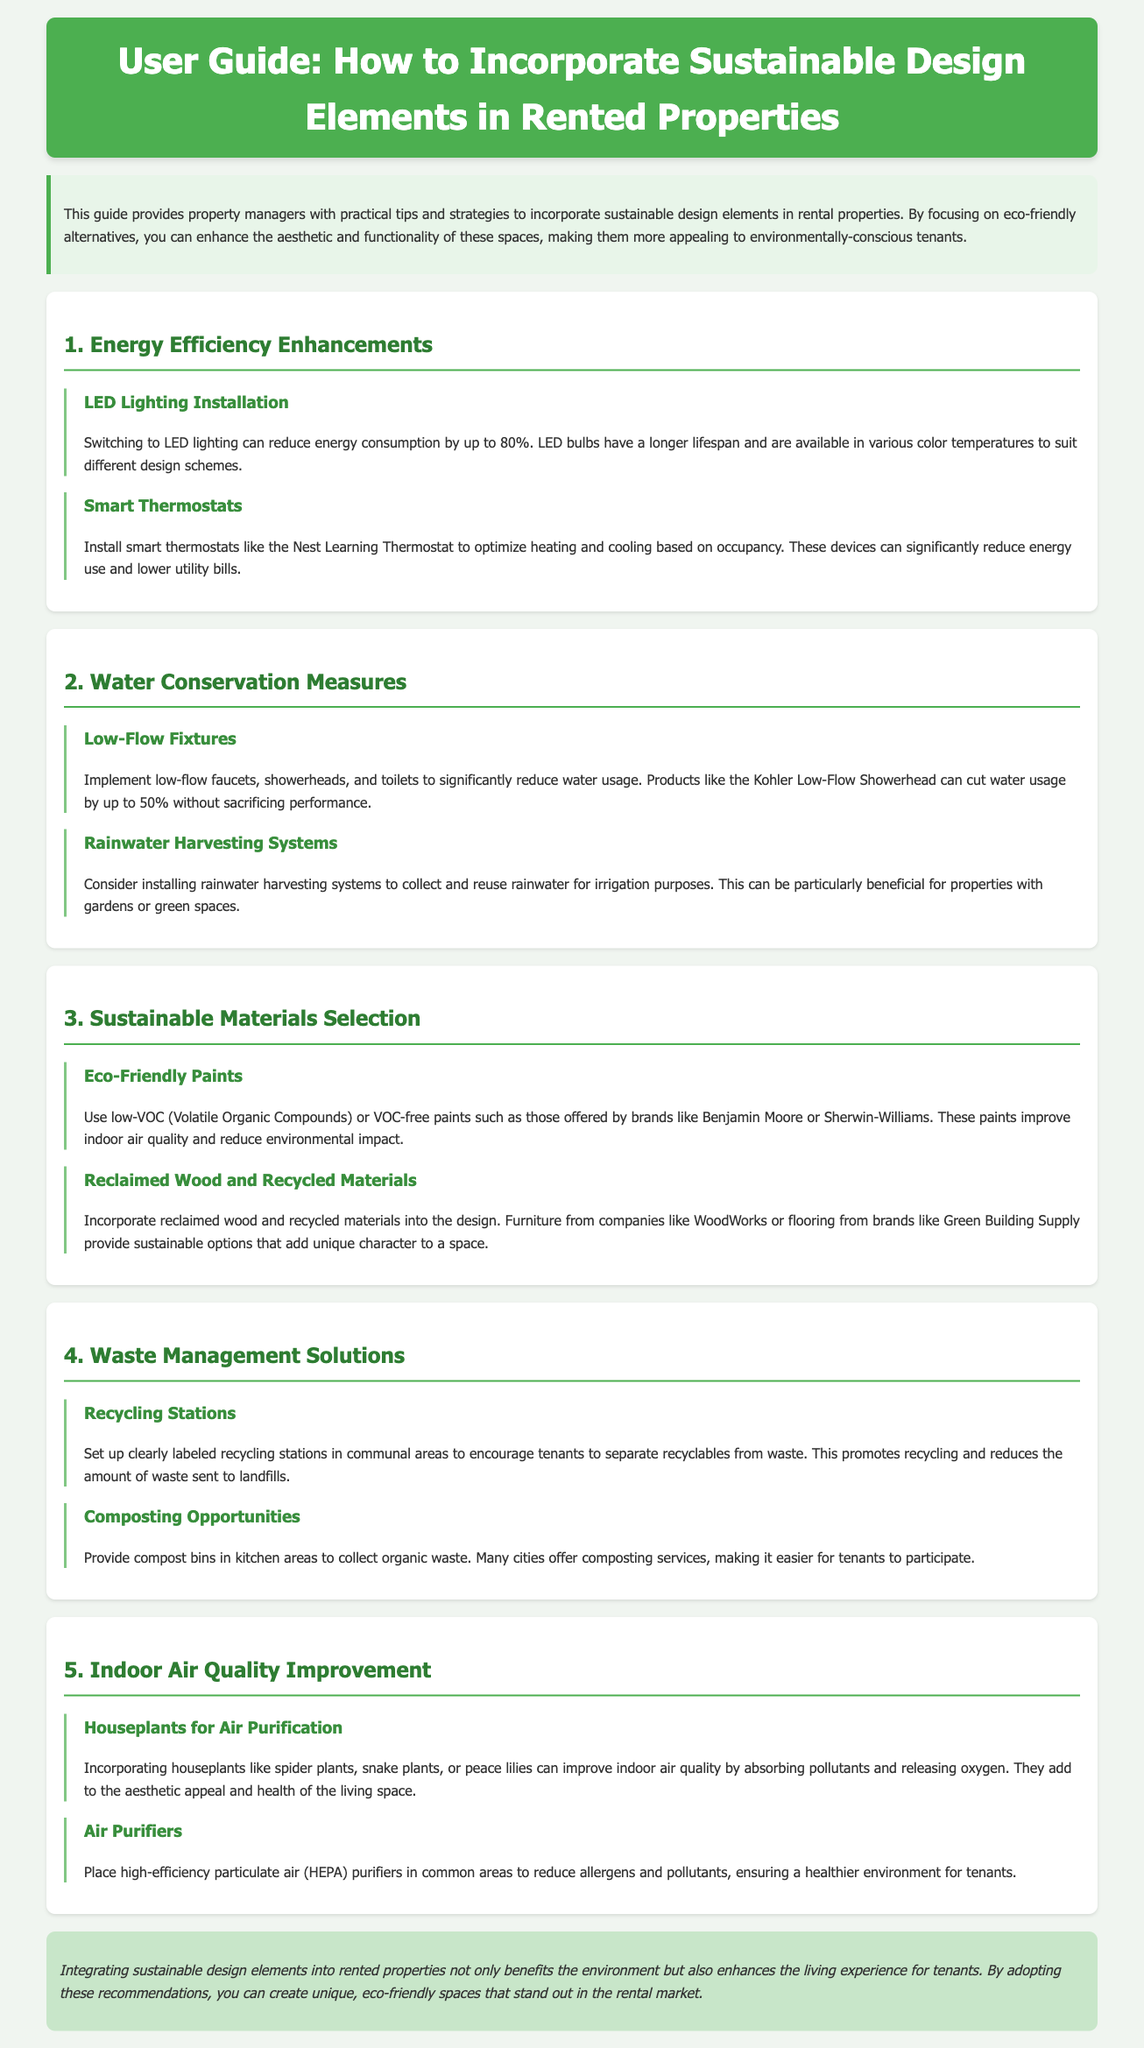What is the title of this user guide? The title is provided in the header of the document, which states the guide's purpose.
Answer: How to Incorporate Sustainable Design Elements in Rented Properties What percentage can LED lighting reduce energy consumption by? The document states a specific percentage reduction in energy consumption when switching to LED lighting.
Answer: up to 80% What is one example of a low-flow fixture mentioned? The document lists products that fall under the category of low-flow fixtures and provides a specific example.
Answer: Kohler Low-Flow Showerhead What should be provided in kitchen areas for organic waste? The document suggests a specific solution for handling organic waste in the kitchen areas of properties.
Answer: Compost bins Which type of plants improve indoor air quality according to the guide? The section on indoor air quality mentions specific types of plants known for their purifying qualities.
Answer: Houseplants What is a benefit of using eco-friendly paints? The document outlines a positive outcome of using eco-friendly paints in rental properties.
Answer: Improve indoor air quality How does installing smart thermostats impact energy use? The guide discusses the effect of smart thermostats on energy consumption in rental properties.
Answer: Significantly reduce energy use What is one method to encourage recycling among tenants? The document suggests a method for promoting recycling practices in communal areas of rental properties.
Answer: Set up clearly labeled recycling stations 